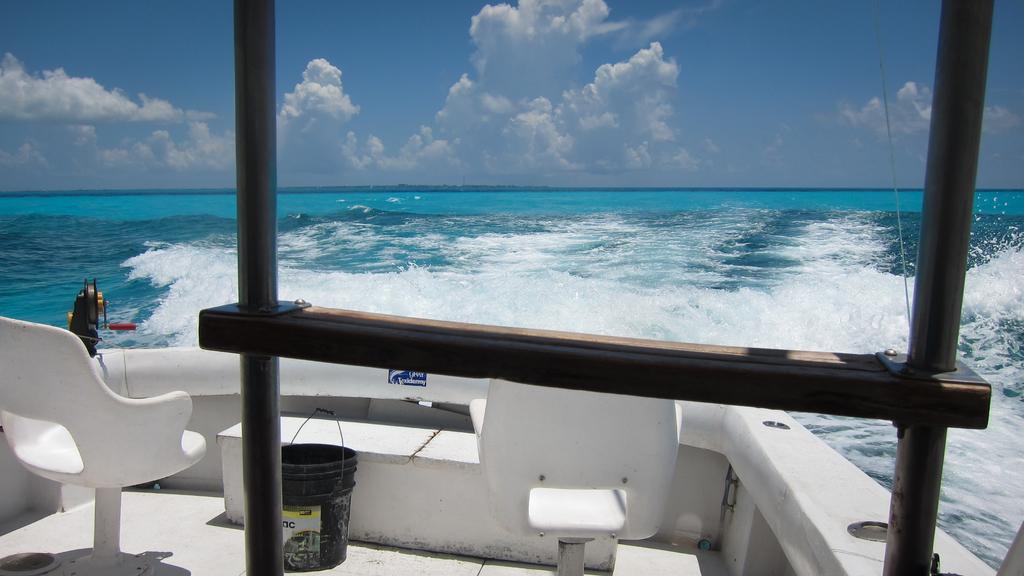Describe this image in one or two sentences. In this image, we can see a chairs, bucket, poles, sticker. Background we can see the sea. Top of the image, there is a cloudy sky. 